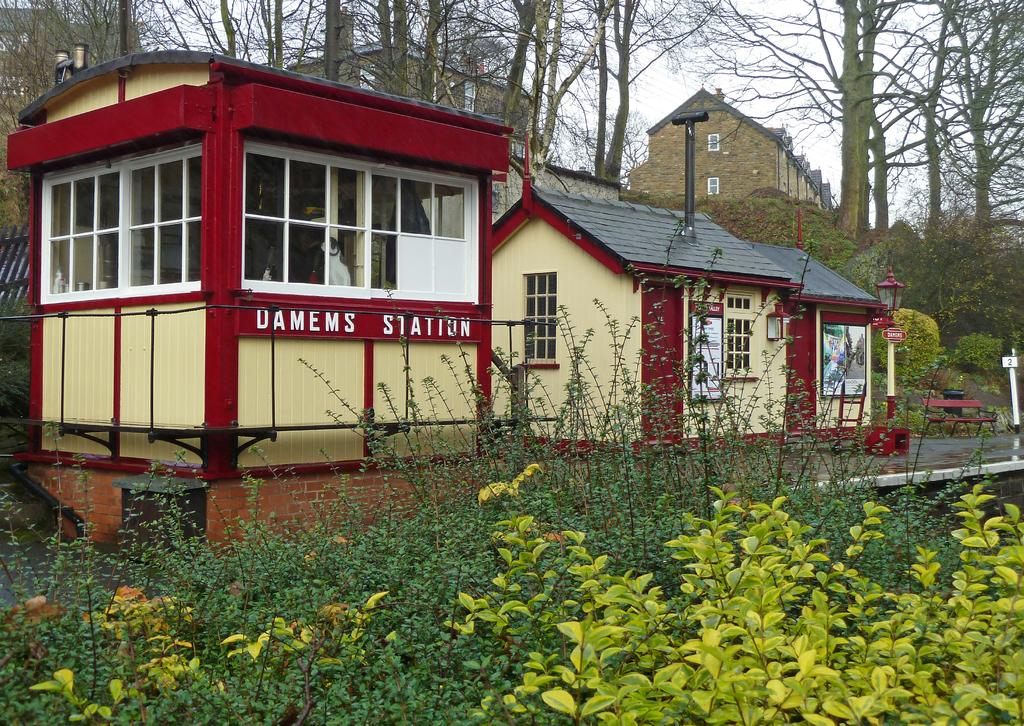What type of structures are visible in the image? There are homes in the image. What type of vegetation can be seen in the image? There are green color plants in the image. What can be seen in the background of the image? There are trees in the background of the image. What is visible at the top of the image? The sky is visible at the top of the image. Where is the cup located in the image? There is no cup present in the image. What type of park is visible in the image? There is no park visible in the image; it features homes, plants, trees, and the sky. 